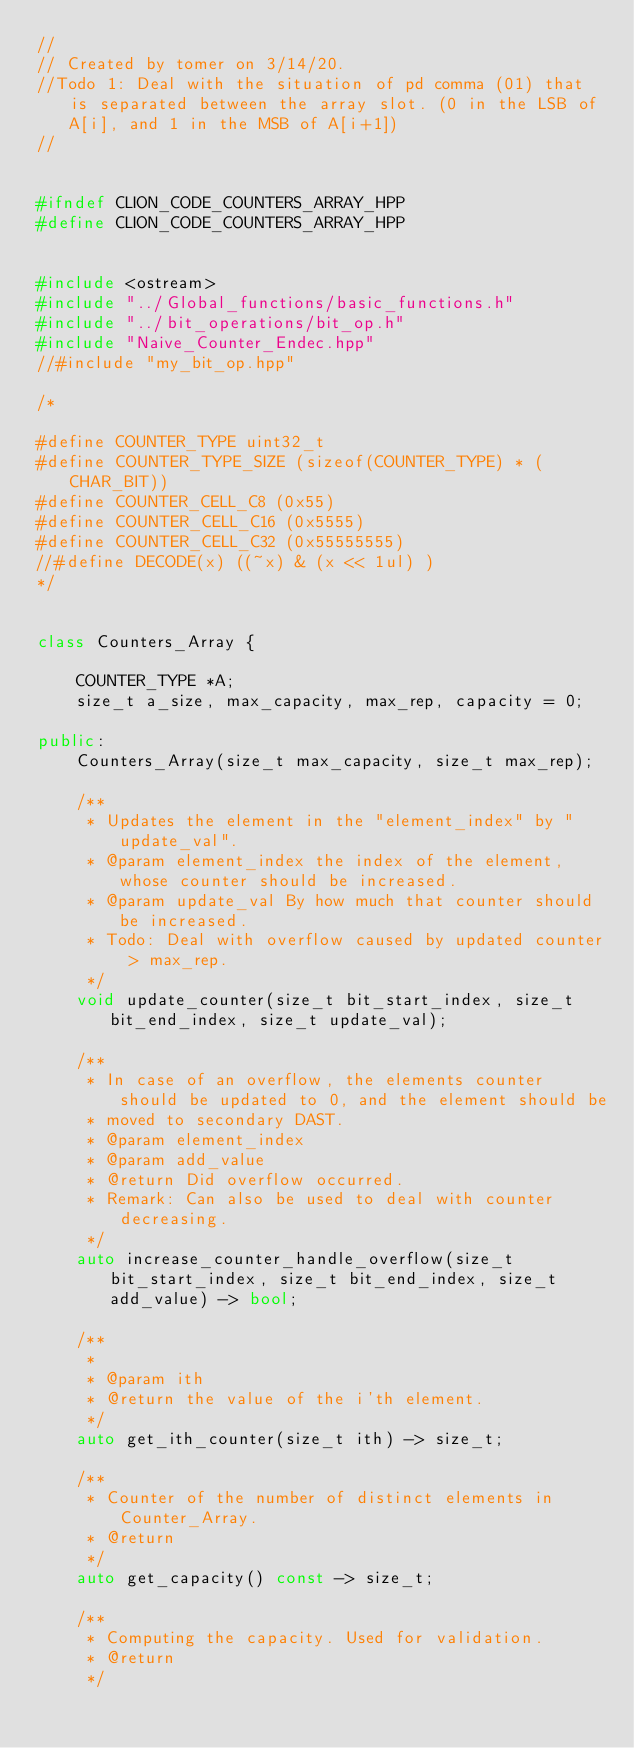<code> <loc_0><loc_0><loc_500><loc_500><_C++_>//
// Created by tomer on 3/14/20.
//Todo 1: Deal with the situation of pd comma (01) that is separated between the array slot. (0 in the LSB of A[i], and 1 in the MSB of A[i+1])
//


#ifndef CLION_CODE_COUNTERS_ARRAY_HPP
#define CLION_CODE_COUNTERS_ARRAY_HPP


#include <ostream>
#include "../Global_functions/basic_functions.h"
#include "../bit_operations/bit_op.h"
#include "Naive_Counter_Endec.hpp"
//#include "my_bit_op.hpp"

/*

#define COUNTER_TYPE uint32_t
#define COUNTER_TYPE_SIZE (sizeof(COUNTER_TYPE) * (CHAR_BIT))
#define COUNTER_CELL_C8 (0x55)
#define COUNTER_CELL_C16 (0x5555)
#define COUNTER_CELL_C32 (0x55555555)
//#define DECODE(x) ((~x) & (x << 1ul) )
*/


class Counters_Array {

    COUNTER_TYPE *A;
    size_t a_size, max_capacity, max_rep, capacity = 0;

public:
    Counters_Array(size_t max_capacity, size_t max_rep);

    /**
     * Updates the element in the "element_index" by "update_val".
     * @param element_index the index of the element, whose counter should be increased.
     * @param update_val By how much that counter should be increased.
     * Todo: Deal with overflow caused by updated counter > max_rep.
     */
    void update_counter(size_t bit_start_index, size_t bit_end_index, size_t update_val);

    /**
     * In case of an overflow, the elements counter should be updated to 0, and the element should be
     * moved to secondary DAST.
     * @param element_index
     * @param add_value
     * @return Did overflow occurred.
     * Remark: Can also be used to deal with counter decreasing.
     */
    auto increase_counter_handle_overflow(size_t bit_start_index, size_t bit_end_index, size_t add_value) -> bool;

    /**
     *
     * @param ith
     * @return the value of the i'th element.
     */
    auto get_ith_counter(size_t ith) -> size_t;

    /**
     * Counter of the number of distinct elements in Counter_Array.
     * @return
     */
    auto get_capacity() const -> size_t;

    /**
     * Computing the capacity. Used for validation.
     * @return
     */</code> 